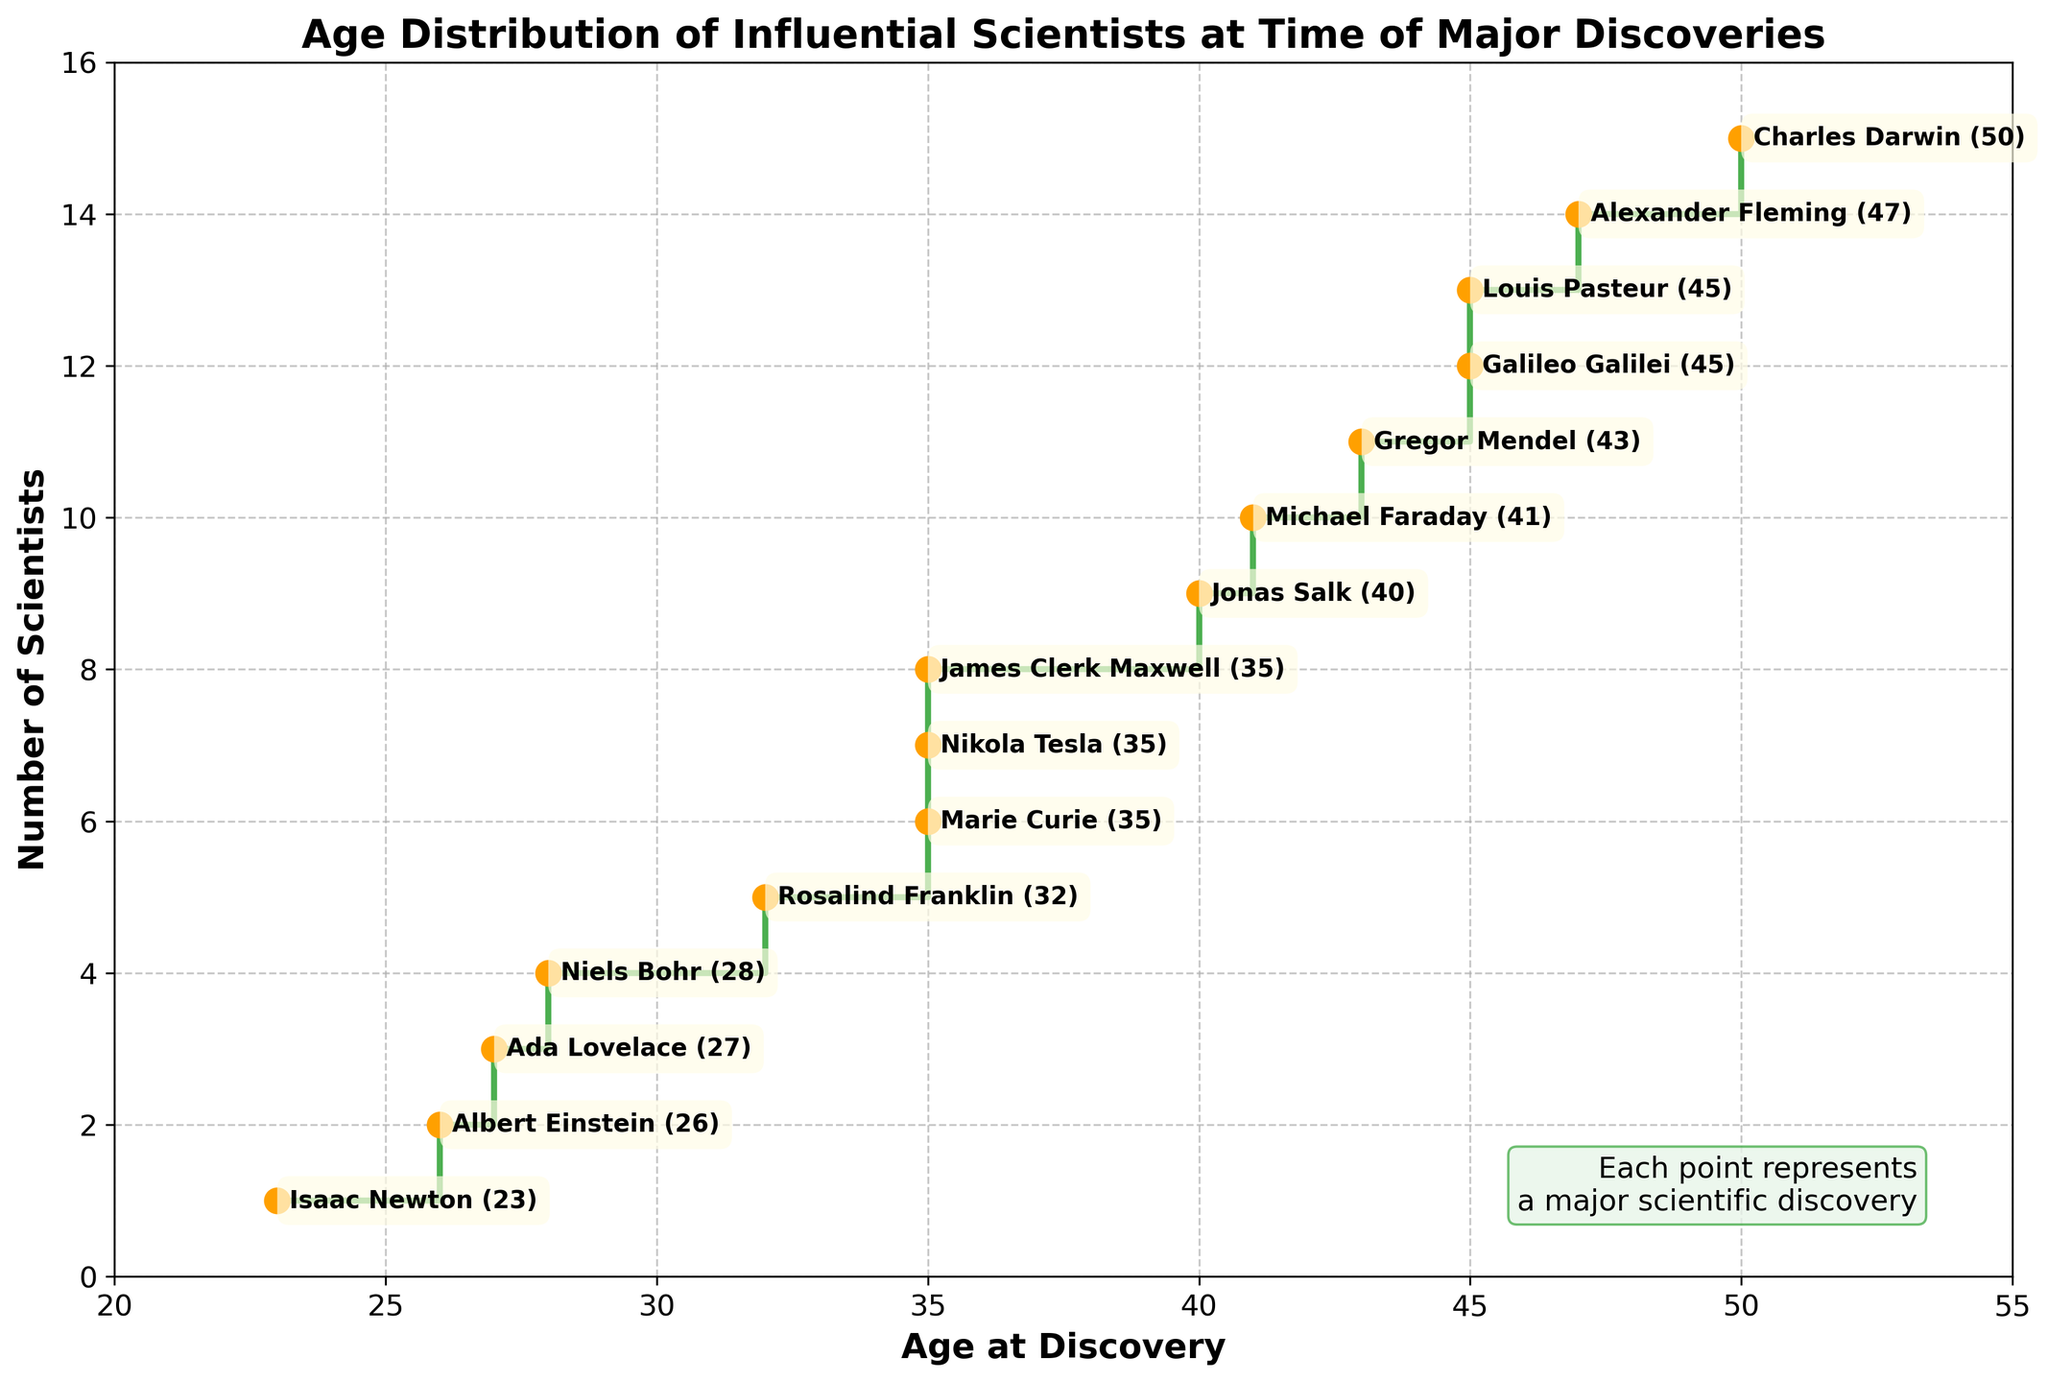What is the title of the plot? The title of the plot is displayed at the top of the figure, typically centered and in bold.
Answer: Age Distribution of Influential Scientists at Time of Major Discoveries What do the x-axis and y-axis represent? The labels of the axes indicate their meanings. The x-axis represents "Age at Discovery," and the y-axis represents "Number of Scientists."
Answer: x-axis: Age at Discovery, y-axis: Number of Scientists How many scientists made their major discoveries before the age of 30? From the plot, count how many blue steps are present before the age tick of 30 on the x-axis. Albert Einstein, Isaac Newton, and Niels Bohr are below 30.
Answer: 3 Between what ages are most scientists making their major discoveries? Observe the most frequent step intervals along the x-axis to determine between what age ranges most steps occur. The higher density of steps is between ages 30 and 45.
Answer: Between 30 and 45 Which scientist was the youngest to make a major discovery? Check the first labeled point after the x-axis starts to see the scientist with the smallest age value.
Answer: Isaac Newton (23) How many scientists made their discoveries at the age of 35? Identify the step at age 35 and count the total number of points at that step. Names include Marie Curie, Nikola Tesla, and James Clerk Maxwell.
Answer: 3 Who made the discovery at the oldest age displayed on the plot? Locate the point farthest to the right on the x-axis and find the corresponding label.
Answer: Charles Darwin (50) Which discovery is associated with Louis Pasteur and at what age did he make it? Look for Louis Pasteur’s labeled data point and read the annotation to find his age and discovery.
Answer: Germ Theory of Disease at age 45 What is the average age of scientists when they made their major discovery? Sum all the ages (26 + 23 + 35 + 35 + 45 + 35 + 41 + 50 + 43 + 28 + 32 + 45 + 27 + 47 + 40) and divide by the number of scientists (15), which is (552 / 15).
Answer: 36.8 How does the plot visually indicate each scientist’s age at the time of discovery? Each age is represented by a step on the stair plot and further marked by an orange point with an annotation mentioning the scientist's name and age.
Answer: By steps and annotated points 